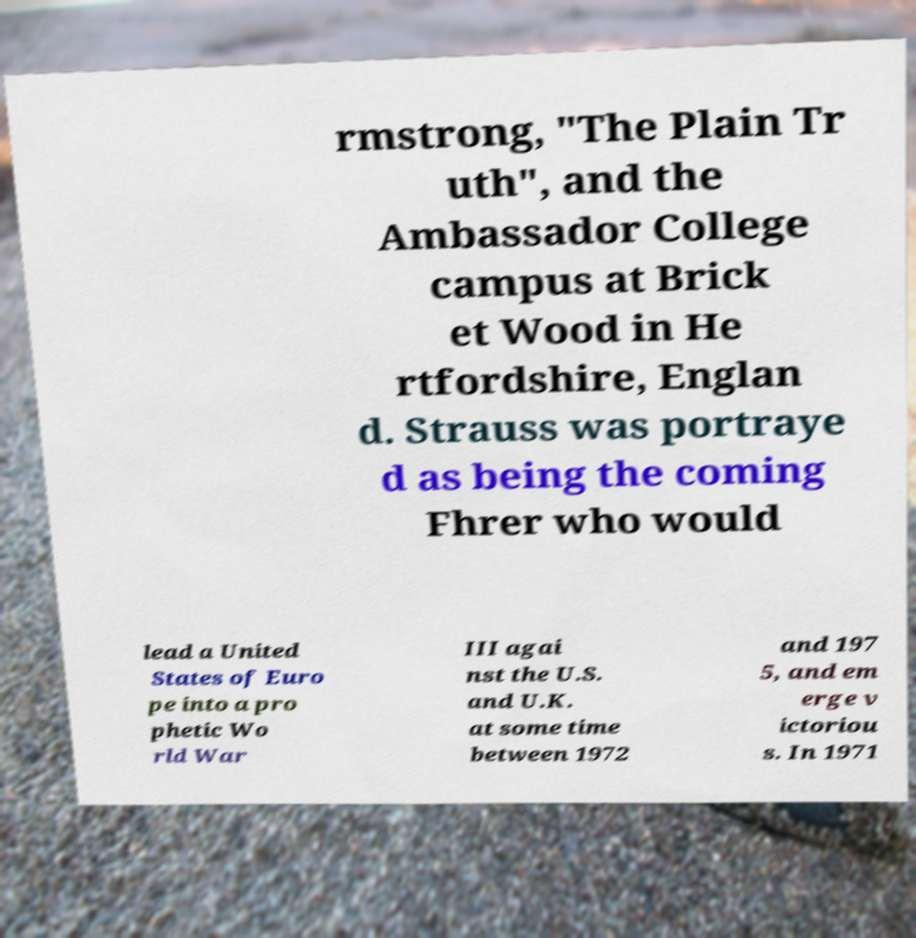For documentation purposes, I need the text within this image transcribed. Could you provide that? rmstrong, "The Plain Tr uth", and the Ambassador College campus at Brick et Wood in He rtfordshire, Englan d. Strauss was portraye d as being the coming Fhrer who would lead a United States of Euro pe into a pro phetic Wo rld War III agai nst the U.S. and U.K. at some time between 1972 and 197 5, and em erge v ictoriou s. In 1971 